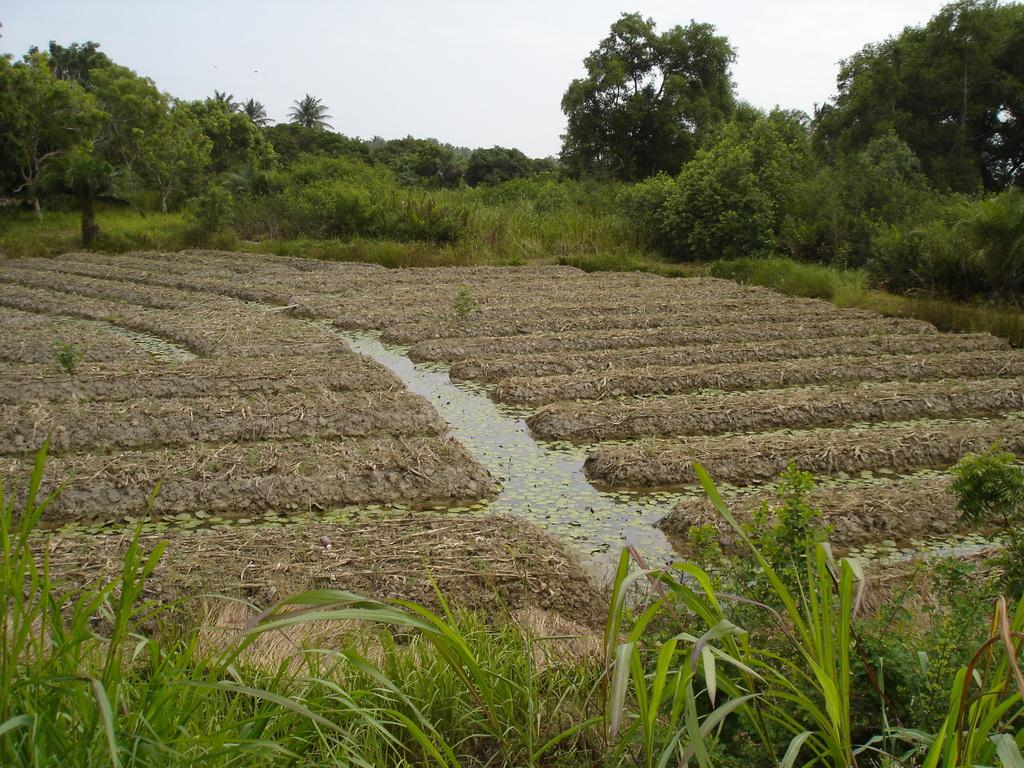What type of landscape is shown in the image? The image appears to depict a field. What type of vegetation can be seen in the image? There are trees, plants, and grass in the image. What is visible at the top of the image? The sky is visible at the top of the image. What type of tooth is visible in the image? There is no tooth present in the image. How many knots can be seen in the furniture in the image? There is no furniture present in the image, so it is not possible to determine the number of knots. 